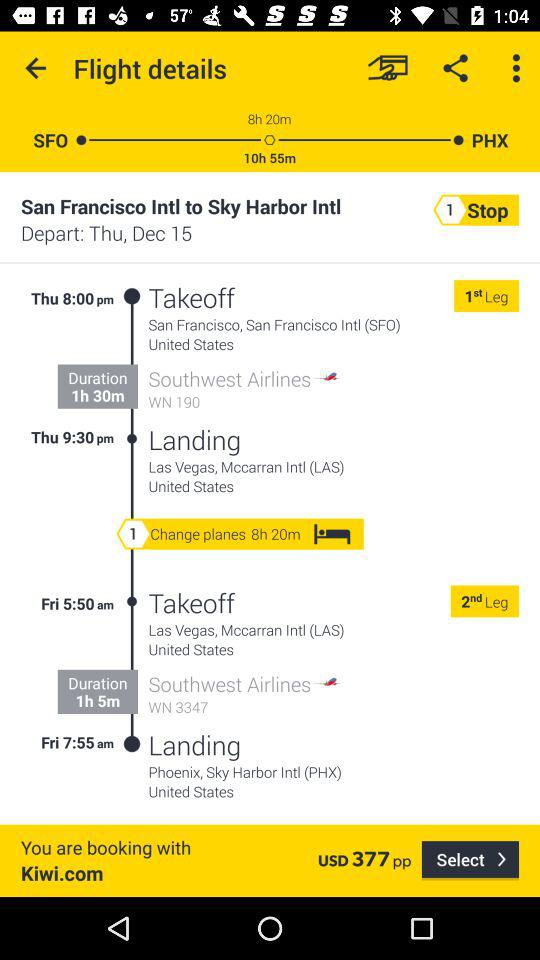When will the flight depart? The flight will depart on Thursday, December 15 at 8:00 p.m. 